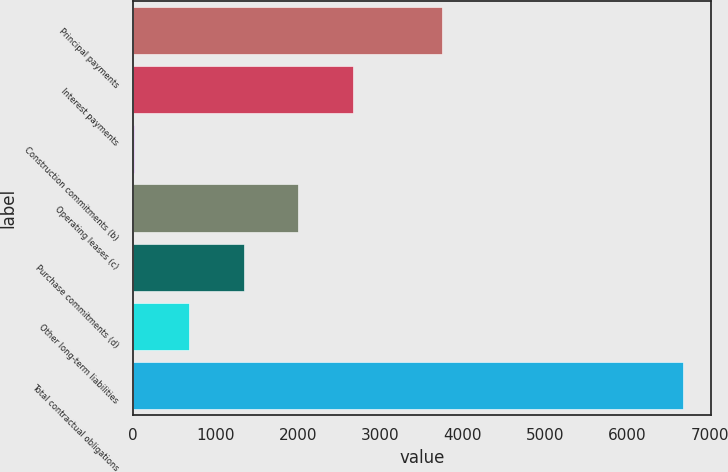Convert chart. <chart><loc_0><loc_0><loc_500><loc_500><bar_chart><fcel>Principal payments<fcel>Interest payments<fcel>Construction commitments (b)<fcel>Operating leases (c)<fcel>Purchase commitments (d)<fcel>Other long-term liabilities<fcel>Total contractual obligations<nl><fcel>3750<fcel>2673.22<fcel>4.7<fcel>2006.09<fcel>1338.96<fcel>671.83<fcel>6676<nl></chart> 